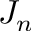<formula> <loc_0><loc_0><loc_500><loc_500>J _ { n }</formula> 